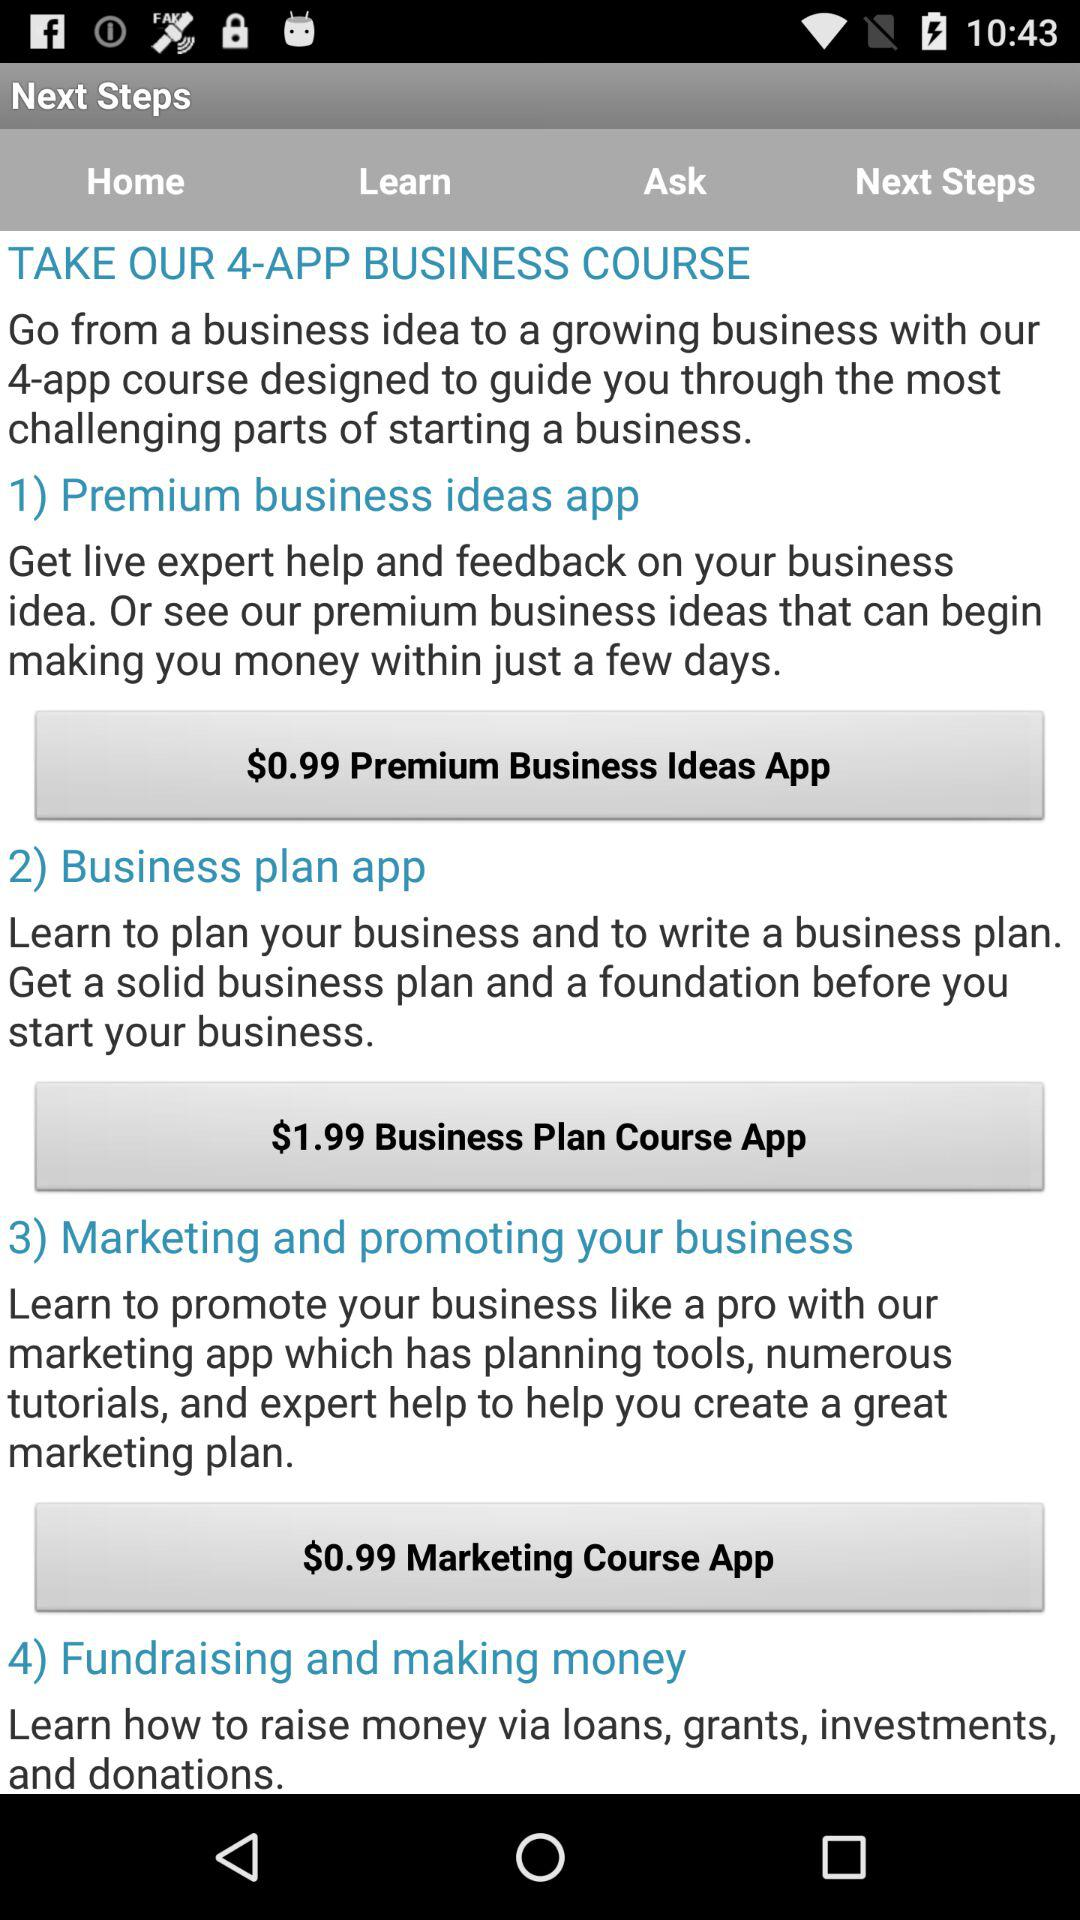What is the price of the "Premium Business Ideas App"? The price of the "Premium Business Ideas App" is $0.99. 